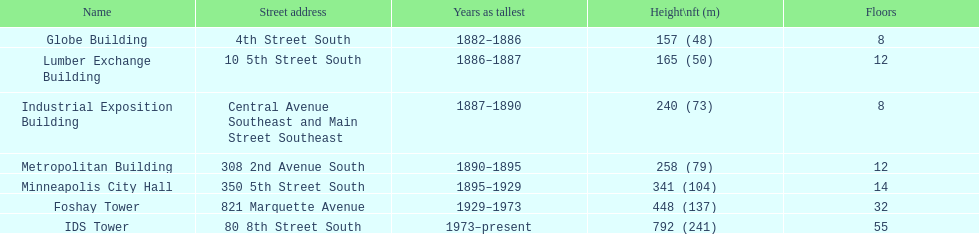How many levels does the foshay tower contain? 32. 